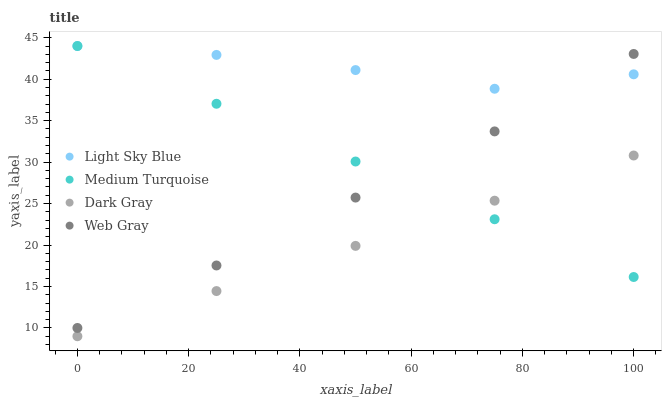Does Dark Gray have the minimum area under the curve?
Answer yes or no. Yes. Does Light Sky Blue have the maximum area under the curve?
Answer yes or no. Yes. Does Web Gray have the minimum area under the curve?
Answer yes or no. No. Does Web Gray have the maximum area under the curve?
Answer yes or no. No. Is Dark Gray the smoothest?
Answer yes or no. Yes. Is Light Sky Blue the roughest?
Answer yes or no. Yes. Is Web Gray the smoothest?
Answer yes or no. No. Is Web Gray the roughest?
Answer yes or no. No. Does Dark Gray have the lowest value?
Answer yes or no. Yes. Does Web Gray have the lowest value?
Answer yes or no. No. Does Medium Turquoise have the highest value?
Answer yes or no. Yes. Does Web Gray have the highest value?
Answer yes or no. No. Is Dark Gray less than Web Gray?
Answer yes or no. Yes. Is Light Sky Blue greater than Dark Gray?
Answer yes or no. Yes. Does Light Sky Blue intersect Web Gray?
Answer yes or no. Yes. Is Light Sky Blue less than Web Gray?
Answer yes or no. No. Is Light Sky Blue greater than Web Gray?
Answer yes or no. No. Does Dark Gray intersect Web Gray?
Answer yes or no. No. 